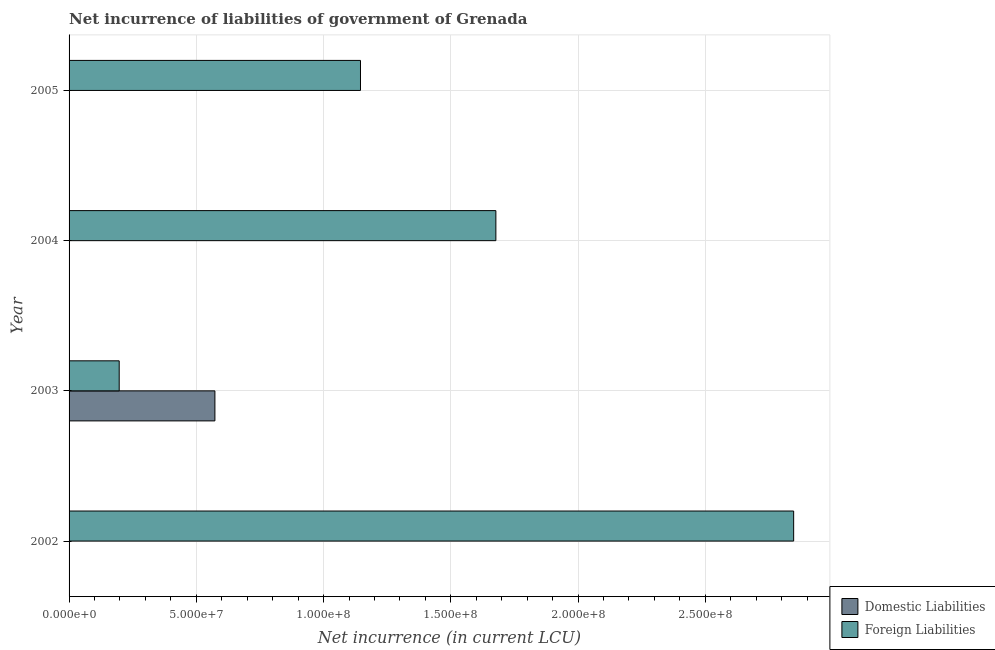Are the number of bars per tick equal to the number of legend labels?
Your answer should be compact. No. How many bars are there on the 1st tick from the top?
Ensure brevity in your answer.  1. What is the label of the 1st group of bars from the top?
Your response must be concise. 2005. What is the net incurrence of foreign liabilities in 2005?
Offer a terse response. 1.14e+08. Across all years, what is the maximum net incurrence of domestic liabilities?
Make the answer very short. 5.73e+07. Across all years, what is the minimum net incurrence of foreign liabilities?
Keep it short and to the point. 1.97e+07. In which year was the net incurrence of foreign liabilities maximum?
Provide a succinct answer. 2002. What is the total net incurrence of domestic liabilities in the graph?
Ensure brevity in your answer.  5.73e+07. What is the difference between the net incurrence of foreign liabilities in 2002 and that in 2005?
Your answer should be compact. 1.70e+08. What is the difference between the net incurrence of domestic liabilities in 2005 and the net incurrence of foreign liabilities in 2003?
Ensure brevity in your answer.  -1.97e+07. What is the average net incurrence of foreign liabilities per year?
Your answer should be very brief. 1.47e+08. In the year 2003, what is the difference between the net incurrence of foreign liabilities and net incurrence of domestic liabilities?
Give a very brief answer. -3.76e+07. In how many years, is the net incurrence of foreign liabilities greater than 250000000 LCU?
Offer a terse response. 1. What is the ratio of the net incurrence of foreign liabilities in 2002 to that in 2003?
Provide a short and direct response. 14.45. Is the net incurrence of foreign liabilities in 2003 less than that in 2005?
Your answer should be very brief. Yes. What is the difference between the highest and the second highest net incurrence of foreign liabilities?
Your response must be concise. 1.17e+08. What is the difference between the highest and the lowest net incurrence of domestic liabilities?
Keep it short and to the point. 5.73e+07. In how many years, is the net incurrence of foreign liabilities greater than the average net incurrence of foreign liabilities taken over all years?
Give a very brief answer. 2. How many bars are there?
Your answer should be compact. 5. Are all the bars in the graph horizontal?
Your answer should be very brief. Yes. Does the graph contain grids?
Give a very brief answer. Yes. Where does the legend appear in the graph?
Give a very brief answer. Bottom right. How are the legend labels stacked?
Provide a succinct answer. Vertical. What is the title of the graph?
Provide a succinct answer. Net incurrence of liabilities of government of Grenada. What is the label or title of the X-axis?
Give a very brief answer. Net incurrence (in current LCU). What is the Net incurrence (in current LCU) of Foreign Liabilities in 2002?
Keep it short and to the point. 2.85e+08. What is the Net incurrence (in current LCU) of Domestic Liabilities in 2003?
Offer a terse response. 5.73e+07. What is the Net incurrence (in current LCU) in Foreign Liabilities in 2003?
Make the answer very short. 1.97e+07. What is the Net incurrence (in current LCU) in Domestic Liabilities in 2004?
Make the answer very short. 0. What is the Net incurrence (in current LCU) of Foreign Liabilities in 2004?
Provide a short and direct response. 1.68e+08. What is the Net incurrence (in current LCU) in Domestic Liabilities in 2005?
Provide a succinct answer. 0. What is the Net incurrence (in current LCU) in Foreign Liabilities in 2005?
Your answer should be very brief. 1.14e+08. Across all years, what is the maximum Net incurrence (in current LCU) of Domestic Liabilities?
Keep it short and to the point. 5.73e+07. Across all years, what is the maximum Net incurrence (in current LCU) of Foreign Liabilities?
Provide a short and direct response. 2.85e+08. Across all years, what is the minimum Net incurrence (in current LCU) of Foreign Liabilities?
Offer a terse response. 1.97e+07. What is the total Net incurrence (in current LCU) of Domestic Liabilities in the graph?
Ensure brevity in your answer.  5.73e+07. What is the total Net incurrence (in current LCU) of Foreign Liabilities in the graph?
Your response must be concise. 5.87e+08. What is the difference between the Net incurrence (in current LCU) in Foreign Liabilities in 2002 and that in 2003?
Give a very brief answer. 2.65e+08. What is the difference between the Net incurrence (in current LCU) of Foreign Liabilities in 2002 and that in 2004?
Keep it short and to the point. 1.17e+08. What is the difference between the Net incurrence (in current LCU) in Foreign Liabilities in 2002 and that in 2005?
Give a very brief answer. 1.70e+08. What is the difference between the Net incurrence (in current LCU) of Foreign Liabilities in 2003 and that in 2004?
Make the answer very short. -1.48e+08. What is the difference between the Net incurrence (in current LCU) in Foreign Liabilities in 2003 and that in 2005?
Keep it short and to the point. -9.48e+07. What is the difference between the Net incurrence (in current LCU) in Foreign Liabilities in 2004 and that in 2005?
Offer a very short reply. 5.32e+07. What is the difference between the Net incurrence (in current LCU) of Domestic Liabilities in 2003 and the Net incurrence (in current LCU) of Foreign Liabilities in 2004?
Provide a succinct answer. -1.10e+08. What is the difference between the Net incurrence (in current LCU) in Domestic Liabilities in 2003 and the Net incurrence (in current LCU) in Foreign Liabilities in 2005?
Offer a terse response. -5.72e+07. What is the average Net incurrence (in current LCU) in Domestic Liabilities per year?
Your answer should be very brief. 1.43e+07. What is the average Net incurrence (in current LCU) in Foreign Liabilities per year?
Your answer should be compact. 1.47e+08. In the year 2003, what is the difference between the Net incurrence (in current LCU) in Domestic Liabilities and Net incurrence (in current LCU) in Foreign Liabilities?
Your answer should be compact. 3.76e+07. What is the ratio of the Net incurrence (in current LCU) in Foreign Liabilities in 2002 to that in 2003?
Your answer should be very brief. 14.45. What is the ratio of the Net incurrence (in current LCU) in Foreign Liabilities in 2002 to that in 2004?
Your answer should be compact. 1.7. What is the ratio of the Net incurrence (in current LCU) of Foreign Liabilities in 2002 to that in 2005?
Give a very brief answer. 2.49. What is the ratio of the Net incurrence (in current LCU) of Foreign Liabilities in 2003 to that in 2004?
Make the answer very short. 0.12. What is the ratio of the Net incurrence (in current LCU) of Foreign Liabilities in 2003 to that in 2005?
Offer a very short reply. 0.17. What is the ratio of the Net incurrence (in current LCU) in Foreign Liabilities in 2004 to that in 2005?
Give a very brief answer. 1.46. What is the difference between the highest and the second highest Net incurrence (in current LCU) in Foreign Liabilities?
Ensure brevity in your answer.  1.17e+08. What is the difference between the highest and the lowest Net incurrence (in current LCU) in Domestic Liabilities?
Offer a terse response. 5.73e+07. What is the difference between the highest and the lowest Net incurrence (in current LCU) in Foreign Liabilities?
Ensure brevity in your answer.  2.65e+08. 